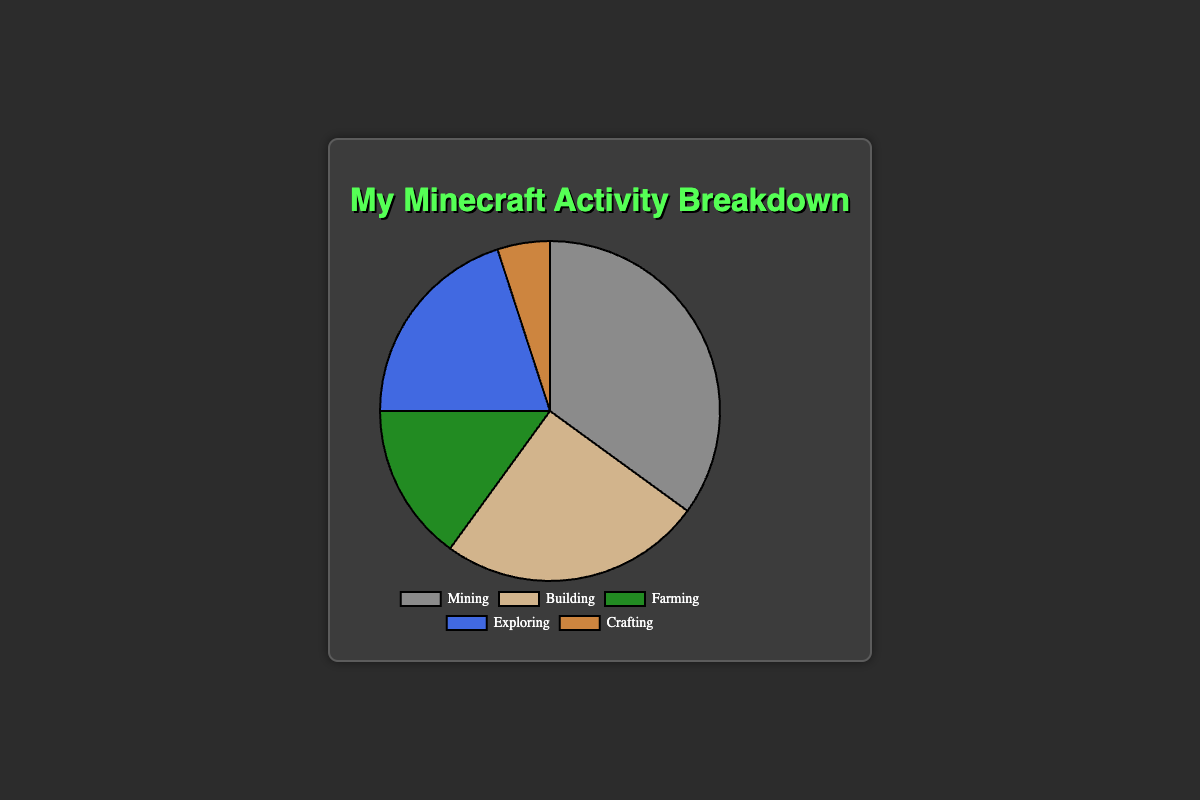what percentage of time is spent on activities other than Mining? To find the percentage of time spent on activities other than Mining, sum the percentages of Building, Farming, Exploring, and Crafting: 25% + 15% + 20% + 5% = 65%
Answer: 65% Which activity has the least amount of time spent on it? According to the percentages given, Crafting has the least amount of time spent at 5%.
Answer: Crafting What is the difference in time spent between the most and least frequent activities? The most frequent activity is Mining (35%), and the least frequent is Crafting (5%). The difference is 35% - 5% = 30%.
Answer: 30% Compared to Farming, how much more time is spent Building? Building takes 25%, and Farming takes 15%. The difference is 25% - 15% = 10%.
Answer: 10% Which activities make up more than half of the total time spent combined? Adding up the percentages for Mining (35%), Building (25%), and Exploring (20%) gives us 35% + 25% + 20% = 80%, which is more than half.
Answer: Mining, Building, Exploring What percentage of time is spent on activities colored green or blue? Farming is green (15%) and Exploring is blue (20%). Summing these gives 15% + 20% = 35%.
Answer: 35% How much more time is spent on Exploring compared to Crafting? Exploring takes 20%, and Crafting takes 5%. The difference is 20% - 5% = 15%.
Answer: 15% What is the average percentage of time spent on Farming and Exploring? To find the average, add the percentages for Farming (15%) and Exploring (20%) and divide by 2. (15% + 20%) / 2 = 17.5%.
Answer: 17.5% Is the time spent on Building greater than the time spent on Farming and Crafting combined? Building takes 25%, while Farming and Crafting combined is 15% + 5% = 20%. Since 25% is greater than 20%, the answer is yes.
Answer: Yes 